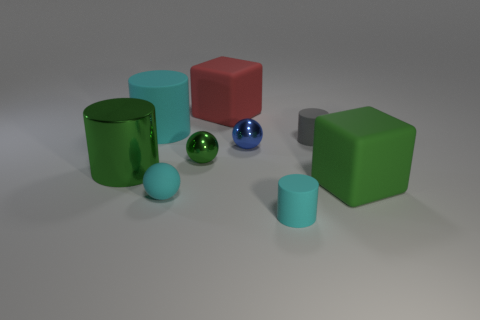Subtract all green blocks. How many blocks are left? 1 Subtract all gray rubber cylinders. How many cylinders are left? 3 Add 1 tiny spheres. How many objects exist? 10 Subtract 0 gray balls. How many objects are left? 9 Subtract all spheres. How many objects are left? 6 Subtract 1 blocks. How many blocks are left? 1 Subtract all purple cylinders. Subtract all brown blocks. How many cylinders are left? 4 Subtract all red balls. How many cyan cylinders are left? 2 Subtract all small things. Subtract all blue rubber balls. How many objects are left? 4 Add 3 matte cylinders. How many matte cylinders are left? 6 